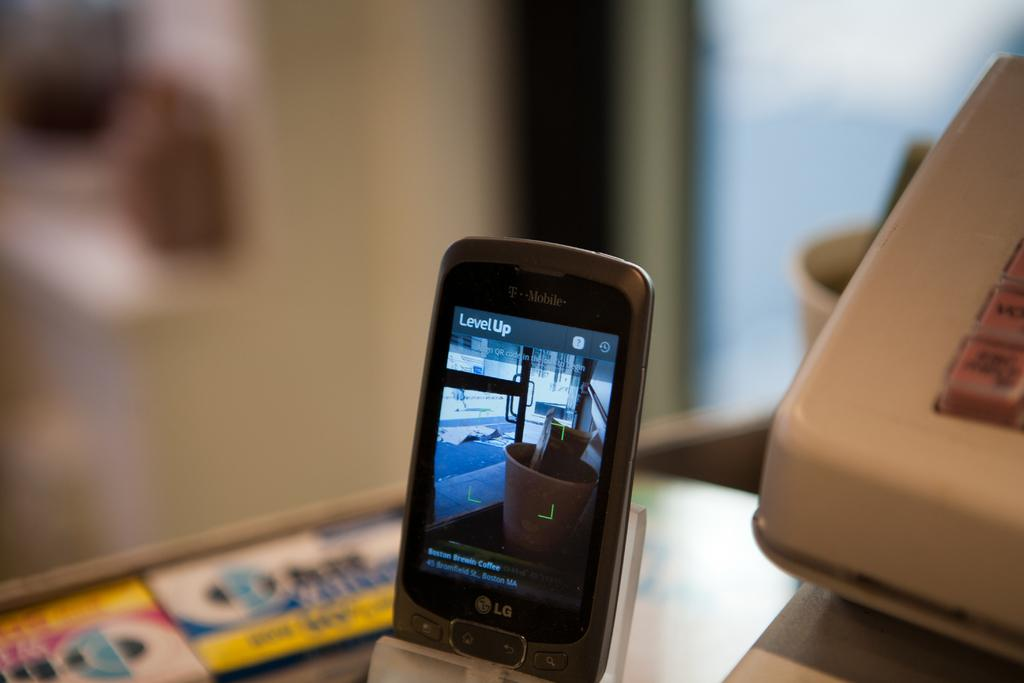<image>
Share a concise interpretation of the image provided. a cell phone propped up with the word level up on the screen 